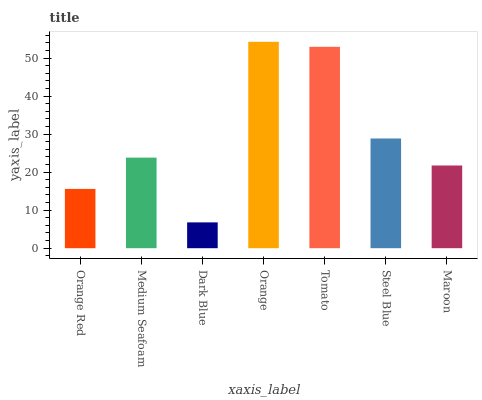Is Dark Blue the minimum?
Answer yes or no. Yes. Is Orange the maximum?
Answer yes or no. Yes. Is Medium Seafoam the minimum?
Answer yes or no. No. Is Medium Seafoam the maximum?
Answer yes or no. No. Is Medium Seafoam greater than Orange Red?
Answer yes or no. Yes. Is Orange Red less than Medium Seafoam?
Answer yes or no. Yes. Is Orange Red greater than Medium Seafoam?
Answer yes or no. No. Is Medium Seafoam less than Orange Red?
Answer yes or no. No. Is Medium Seafoam the high median?
Answer yes or no. Yes. Is Medium Seafoam the low median?
Answer yes or no. Yes. Is Tomato the high median?
Answer yes or no. No. Is Steel Blue the low median?
Answer yes or no. No. 